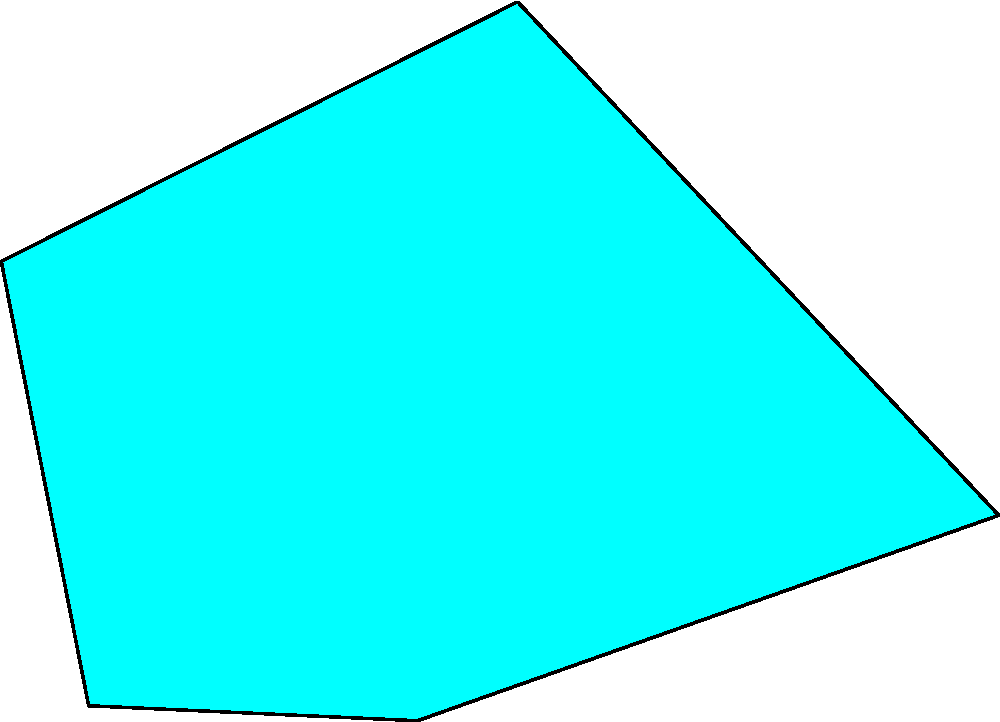Based on the radar chart showing visual elements in science fiction movie posters, which subgenre is most likely to feature prominently dystopian and wasteland imagery? To answer this question, we need to analyze the radar chart for each subgenre:

1. Cyberpunk (cyan):
   - Highest in Neon and Futuristic elements
   - Low in Dystopian and Wasteland elements

2. Space Opera (purple):
   - Highest in Space and Futuristic elements
   - Low in Dystopian and Wasteland elements

3. Post-Apocalyptic (orange):
   - Highest in Dystopian and Wasteland elements
   - Lower in other elements

Comparing the three subgenres:
- Cyberpunk and Space Opera have low values for Dystopian and Wasteland elements
- Post-Apocalyptic has the highest values for both Dystopian and Wasteland elements

Therefore, the subgenre most likely to feature prominently dystopian and wasteland imagery is Post-Apocalyptic.
Answer: Post-Apocalyptic 